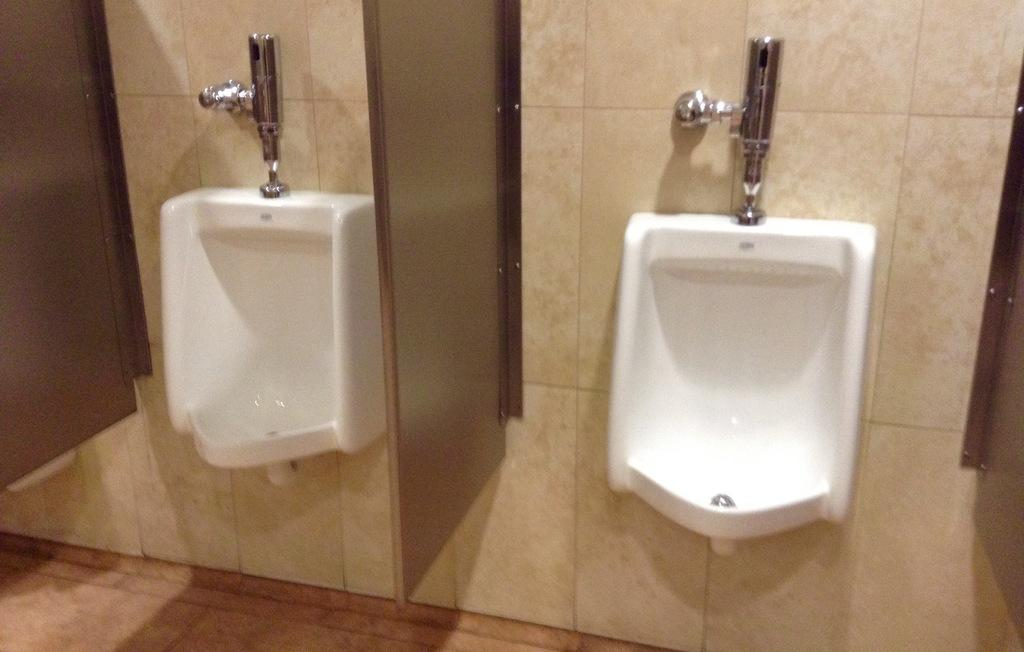What type of fixtures are present in the image? There are toilet sinks in the image. What can be seen in the background of the image? There is a wall in the background of the image. What type of leaf is falling from the ceiling in the image? There is no leaf present in the image; it features toilet sinks and a wall in the background. 